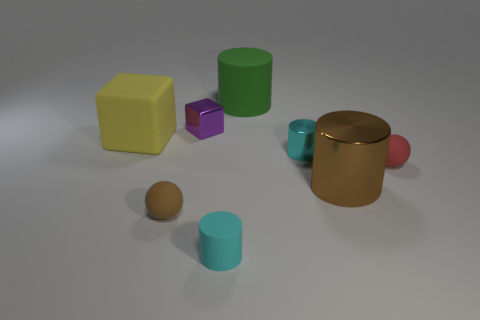The large matte block is what color? The large matte block in the image is yellow, displaying a soft and evenly diffused surface, which contrasts nicely with the other objects that exhibit their own distinct textures and hues. 